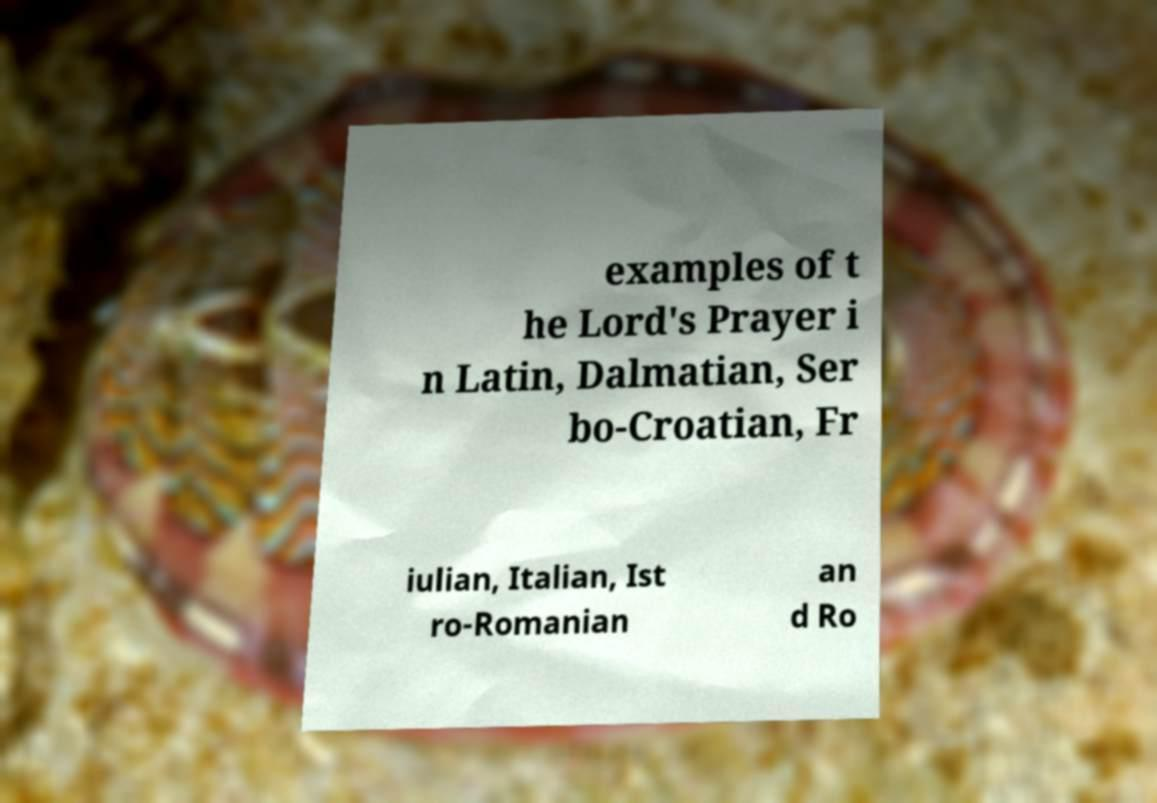Can you read and provide the text displayed in the image?This photo seems to have some interesting text. Can you extract and type it out for me? examples of t he Lord's Prayer i n Latin, Dalmatian, Ser bo-Croatian, Fr iulian, Italian, Ist ro-Romanian an d Ro 